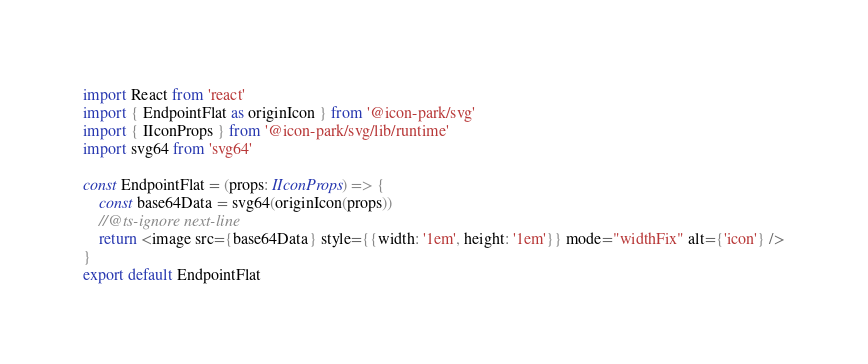<code> <loc_0><loc_0><loc_500><loc_500><_TypeScript_>import React from 'react'
import { EndpointFlat as originIcon } from '@icon-park/svg'
import { IIconProps } from '@icon-park/svg/lib/runtime'
import svg64 from 'svg64'

const EndpointFlat = (props: IIconProps) => {
    const base64Data = svg64(originIcon(props))
    //@ts-ignore next-line
    return <image src={base64Data} style={{width: '1em', height: '1em'}} mode="widthFix" alt={'icon'} />
}
export default EndpointFlat
</code> 